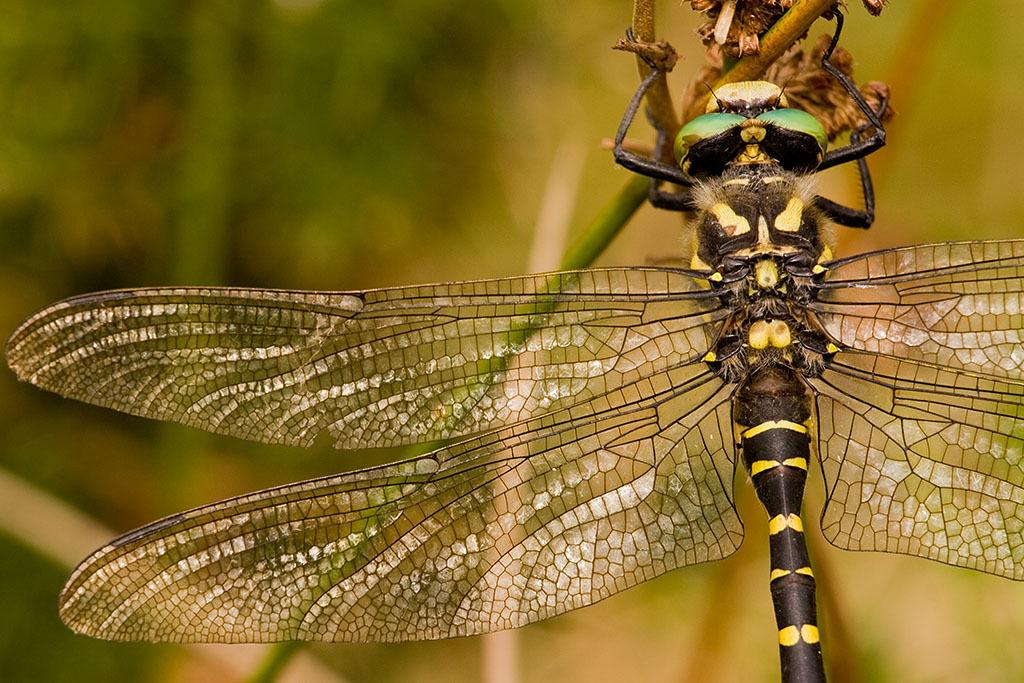What is the main subject of the image? The main subject of the image is a grasshopper. Where is the grasshopper located in the image? The grasshopper is standing on a flower. Can you describe the background of the image? The background of the image is blurred. How many visitors are present in the image? There is no mention of visitors in the image; it only features a grasshopper on a flower. 